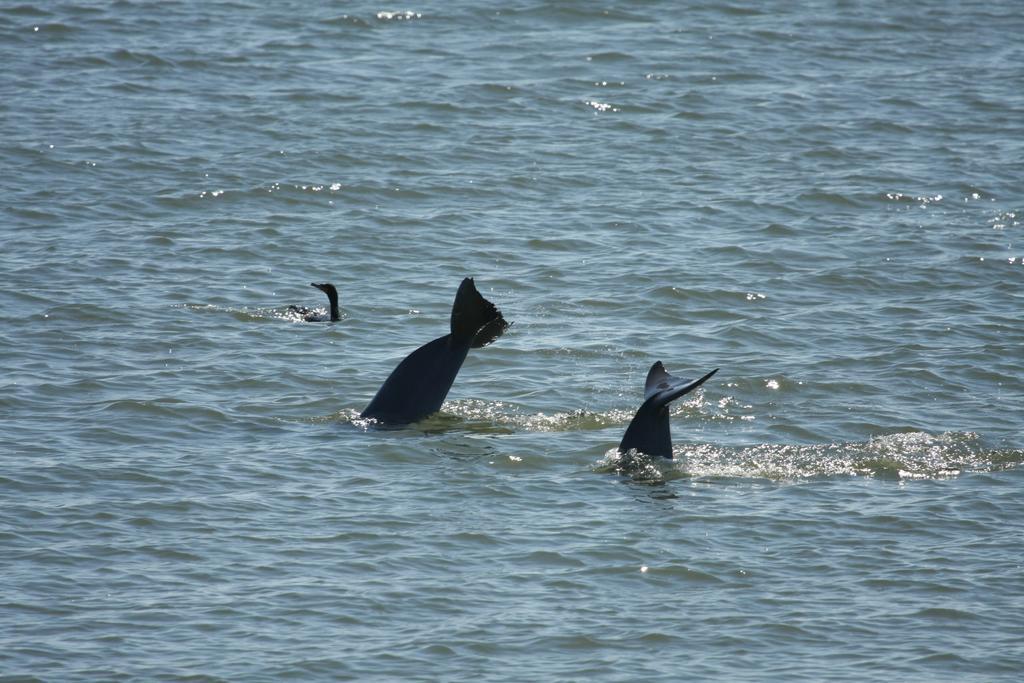Could you give a brief overview of what you see in this image? In the center of the image, we can see whales in the water. 